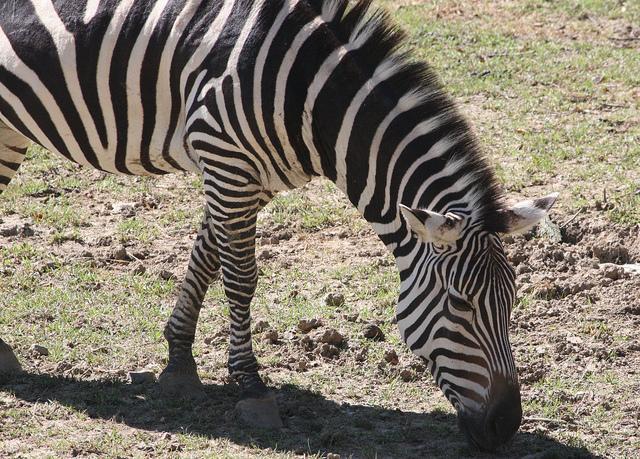How many zebras are here?
Give a very brief answer. 1. 